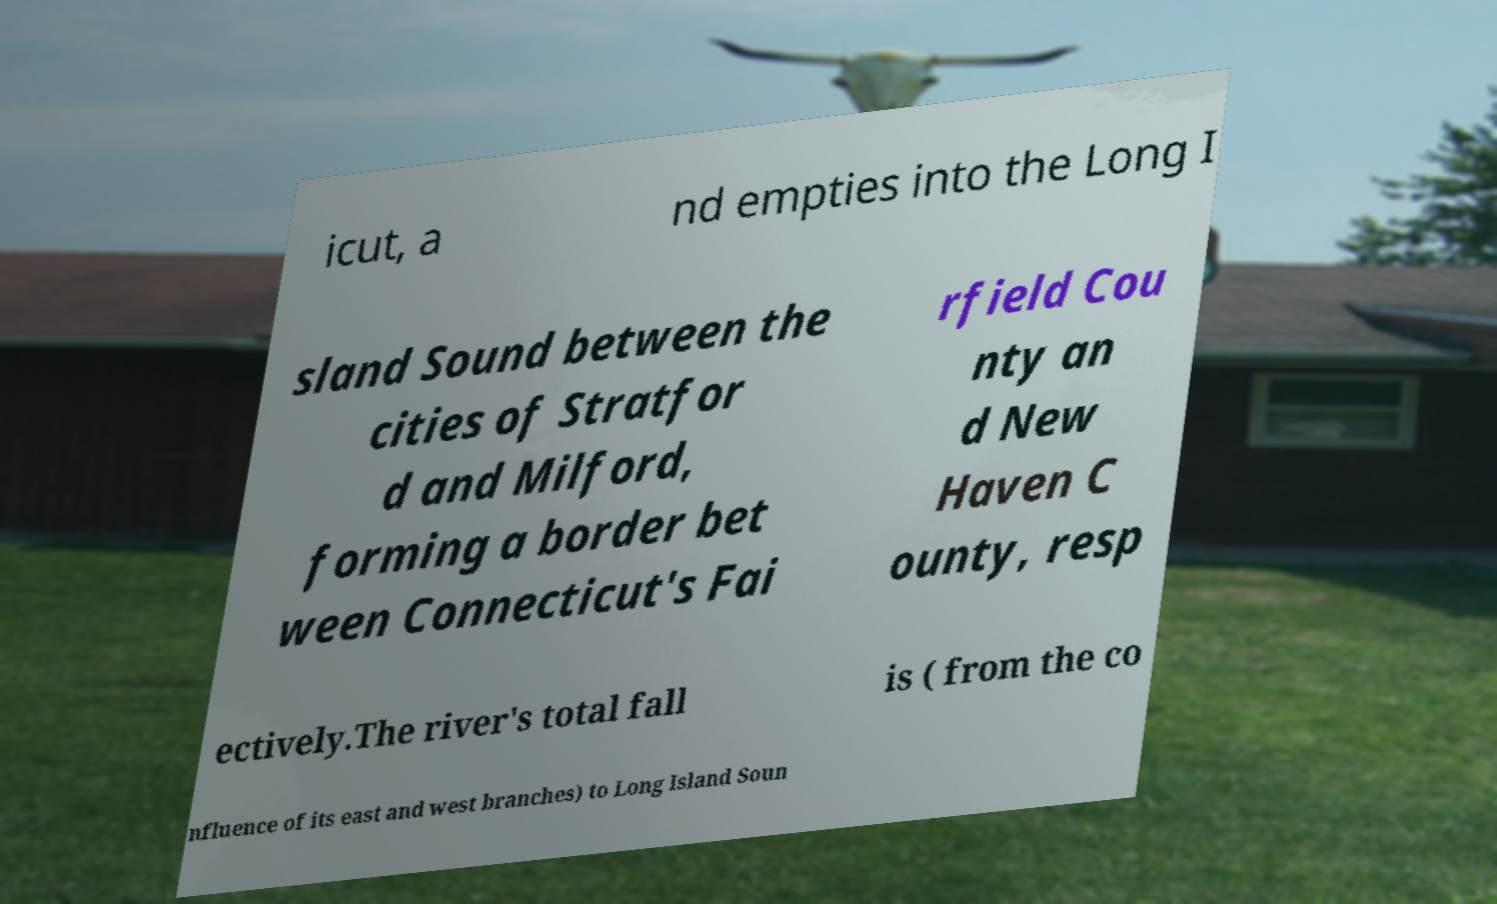Could you extract and type out the text from this image? icut, a nd empties into the Long I sland Sound between the cities of Stratfor d and Milford, forming a border bet ween Connecticut's Fai rfield Cou nty an d New Haven C ounty, resp ectively.The river's total fall is ( from the co nfluence of its east and west branches) to Long Island Soun 